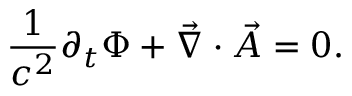<formula> <loc_0><loc_0><loc_500><loc_500>\frac { 1 } { c ^ { 2 } } \partial _ { t } \Phi + \vec { \nabla } \cdot \vec { A } = 0 .</formula> 